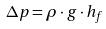Convert formula to latex. <formula><loc_0><loc_0><loc_500><loc_500>\Delta p = \rho \cdot g \cdot h _ { f }</formula> 